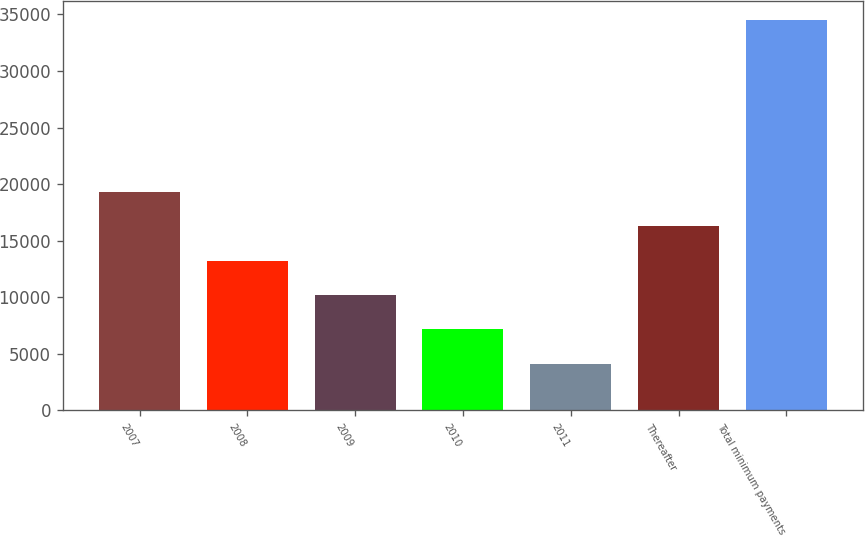<chart> <loc_0><loc_0><loc_500><loc_500><bar_chart><fcel>2007<fcel>2008<fcel>2009<fcel>2010<fcel>2011<fcel>Thereafter<fcel>Total minimum payments<nl><fcel>19307<fcel>13242.2<fcel>10209.8<fcel>7177.4<fcel>4145<fcel>16274.6<fcel>34469<nl></chart> 